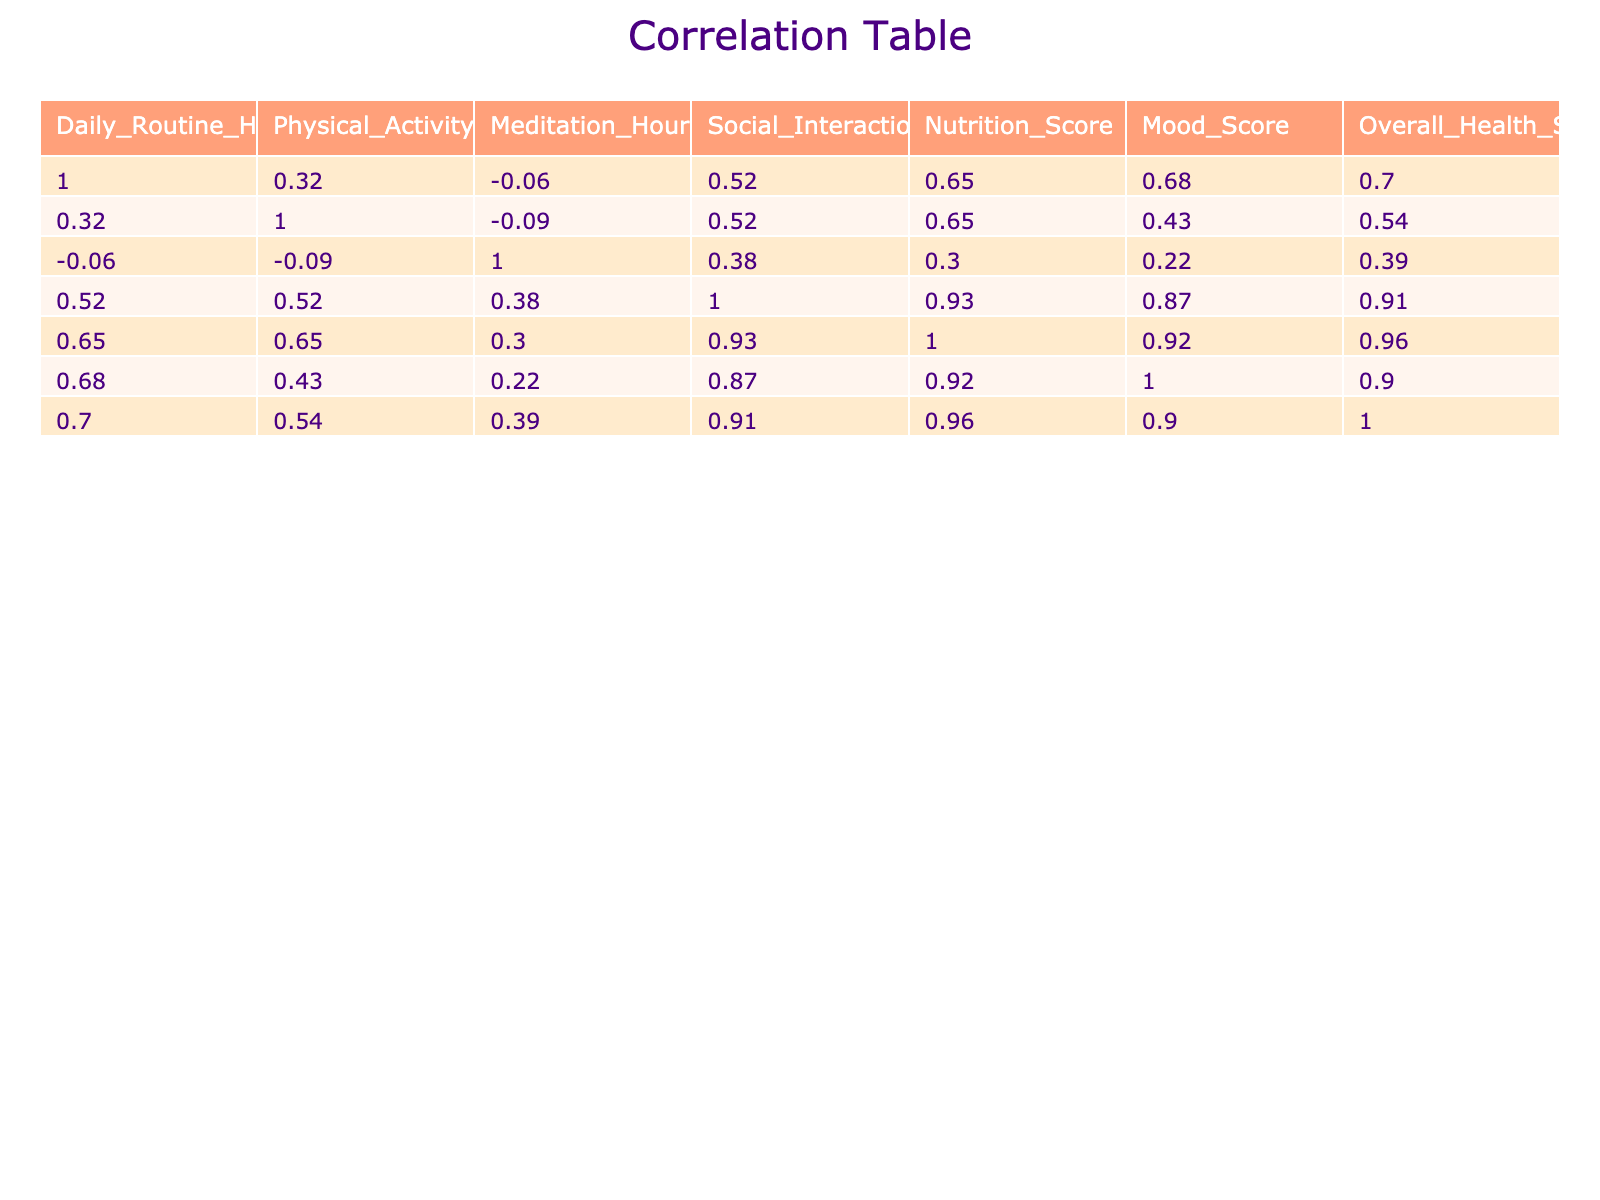What is the correlation between Physical Activity Hours and Mood Score? The correlation value between Physical Activity Hours and Mood Score is 0.32, indicating a weak positive relationship where increased physical activity is associated with slightly improved mood.
Answer: 0.32 What is the Mood Score of the entry with the highest Nutrition Score? The highest Nutrition Score is 9, which corresponds to the Mood Score of 9 in the same row, indicating a strong relationship between nutrition and mood in this instance.
Answer: 9 What is the average Mood Score across all entries? There are 10 Mood Scores: 8, 5, 9, 4, 7, 3, 8, 6, 3, 7. Adding these together gives 60, and dividing by 10 results in an average of 6.
Answer: 6 Does having more Social Interactions correlate with a higher Overall Health Score? Yes, the correlation between Social Interactions Score and Overall Health Score is 0.48, indicating a moderate positive relationship where more social interactions are generally associated with better health scores.
Answer: Yes What is the difference in Overall Health Scores between the highest and lowest Mood Scores? The highest Mood Score is 9 (which has an Overall Health Score of 8), and the lowest Mood Score is 3 (with an Overall Health Score of 2). The difference is 8 - 2 = 6.
Answer: 6 What is the correlation between Daily Routine Hours and Nutrition Score? The correlation value is 0.34, showing a weak positive relationship indicating that as daily routine hours increase, nutrition scores slightly improve.
Answer: 0.34 Are there any entries where the Mood Score is below 5? Yes, there are entries with Mood Scores of 4, 3, and 3; thus confirming that some entries have scores below 5.
Answer: Yes What is the average of the Physical Activity Hours only for the rows where Nutrition Score is 8 or higher? The applicable entries with Nutrition Scores of 8 or higher are three: (1, 7, 1). The average is calculated as (1 + 1 + 2) / 3 = 1.33.
Answer: 1.33 How many rows have a Mood Score of 8 or higher? There are four entries with a Mood Score of 8 or higher, namely the rows with scores of 8, 9, 8, and 8.
Answer: 4 